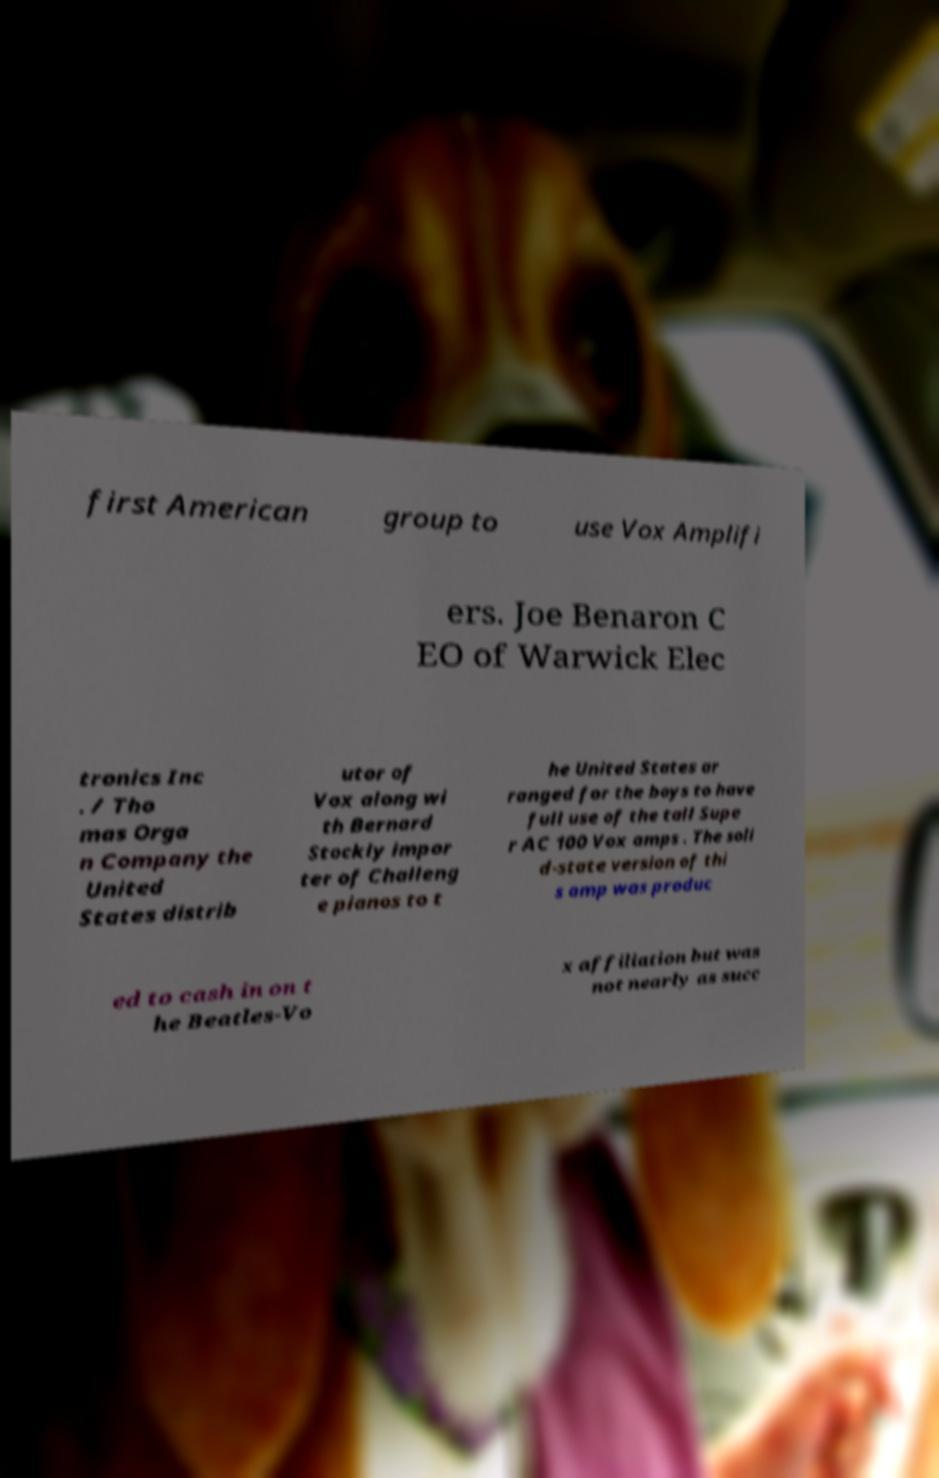I need the written content from this picture converted into text. Can you do that? first American group to use Vox Amplifi ers. Joe Benaron C EO of Warwick Elec tronics Inc . / Tho mas Orga n Company the United States distrib utor of Vox along wi th Bernard Stockly impor ter of Challeng e pianos to t he United States ar ranged for the boys to have full use of the tall Supe r AC 100 Vox amps . The soli d-state version of thi s amp was produc ed to cash in on t he Beatles-Vo x affiliation but was not nearly as succ 